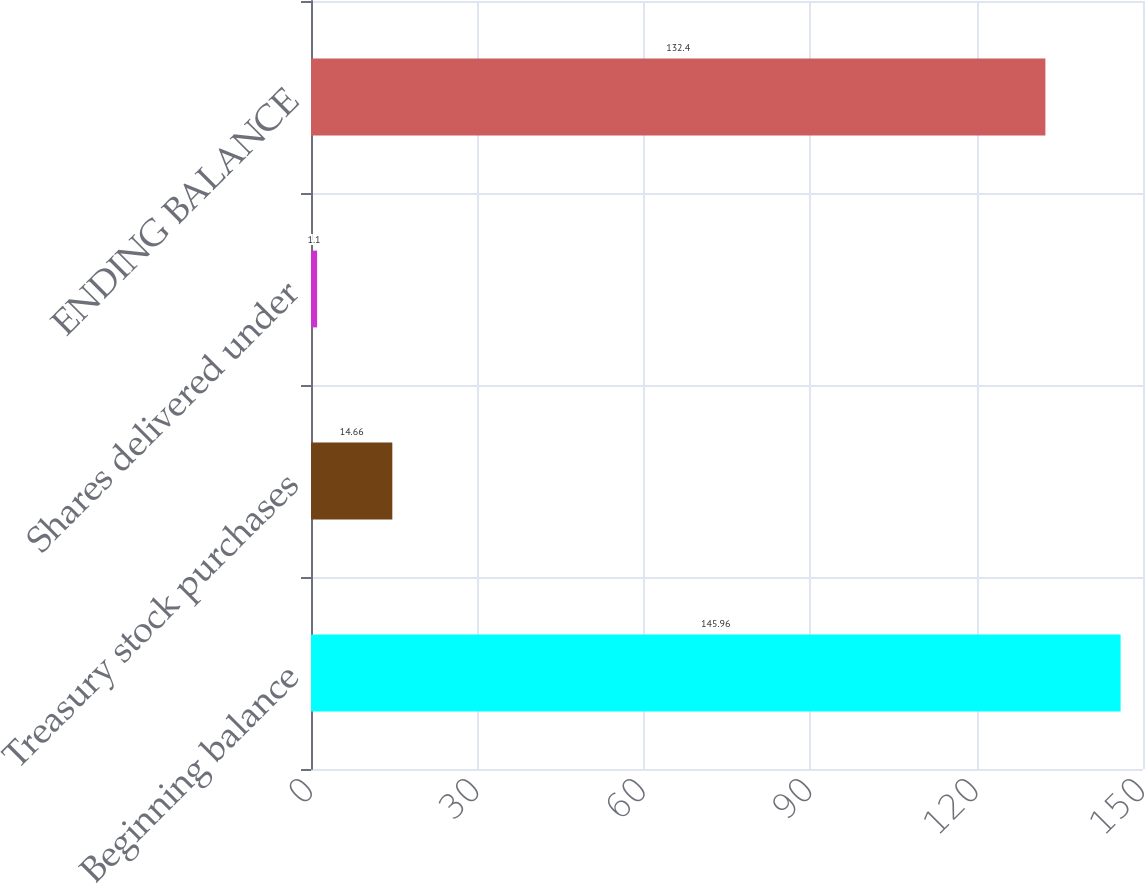<chart> <loc_0><loc_0><loc_500><loc_500><bar_chart><fcel>Beginning balance<fcel>Treasury stock purchases<fcel>Shares delivered under<fcel>ENDING BALANCE<nl><fcel>145.96<fcel>14.66<fcel>1.1<fcel>132.4<nl></chart> 